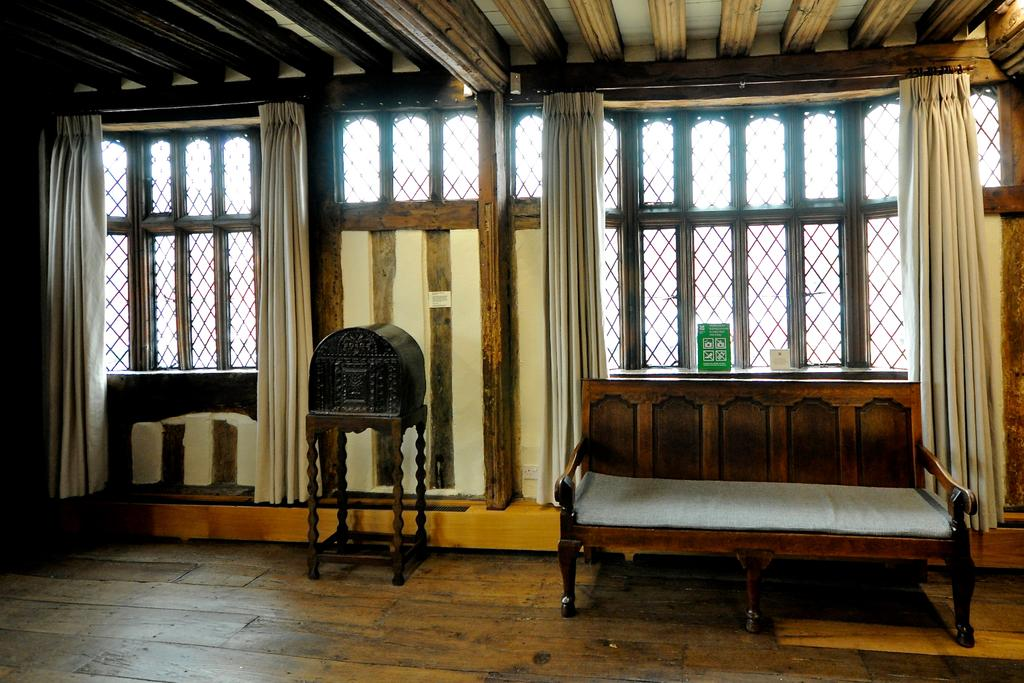What is the color of the box in the image? The box in the image is brown-colored. What type of furniture is present in the image? There is a wooden couch in the image. What can be seen in the background of the image? There are windows in the background of the image. What type of window treatment is present in the image? There are white-colored curtains associated with the windows. How many geese are sitting on the wooden couch in the image? There are no geese present in the image; it features a brown-colored box, a wooden couch, windows, and white-colored curtains. What type of snake can be seen slithering across the brown-colored box in the image? There is no snake present in the image; it only features a brown-colored box, a wooden couch, windows, and white-colored curtains. 